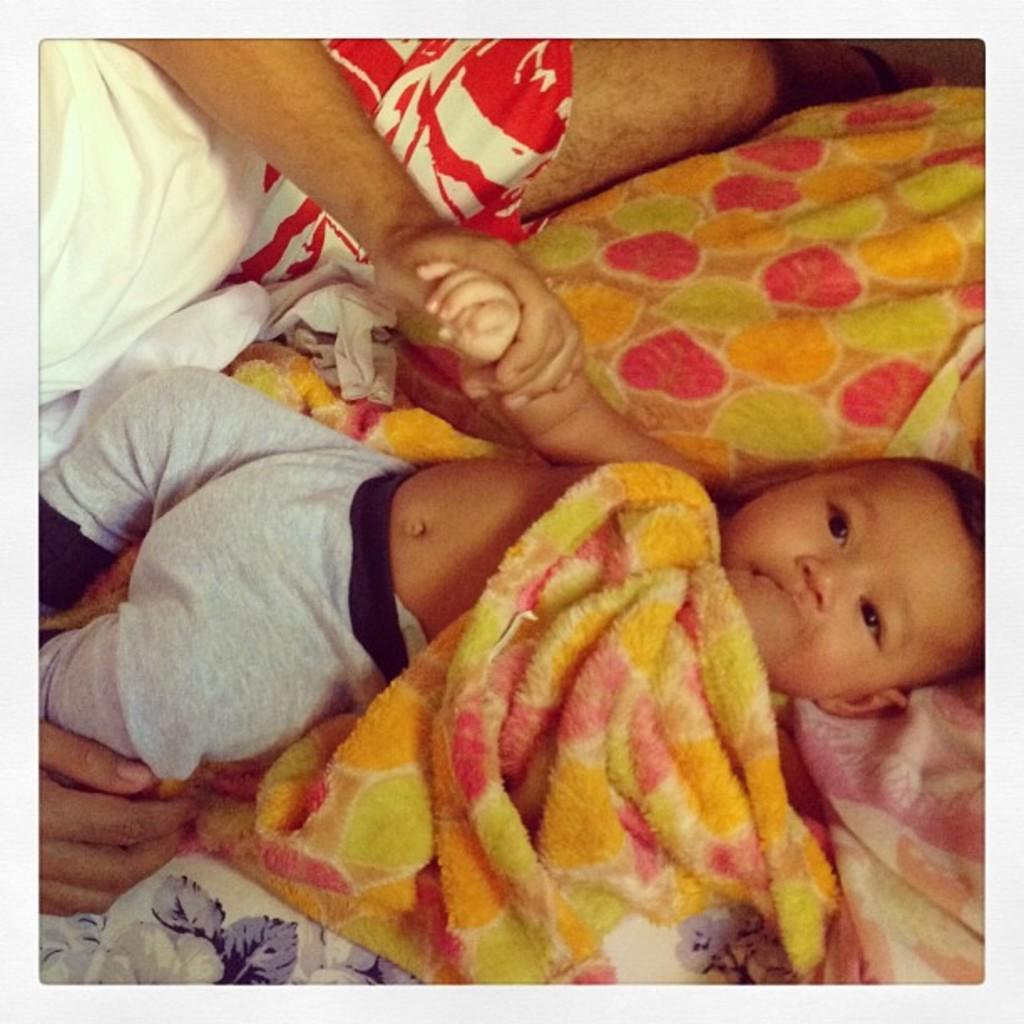Please provide a concise description of this image. In the center of this picture we can see a kid seems to be lying on the bed. In the left corner we can see the hand of a person. In the background we can see another person seems to be lying on the bed and holding the hand of a kid, and we can see the blanket in the foreground. 